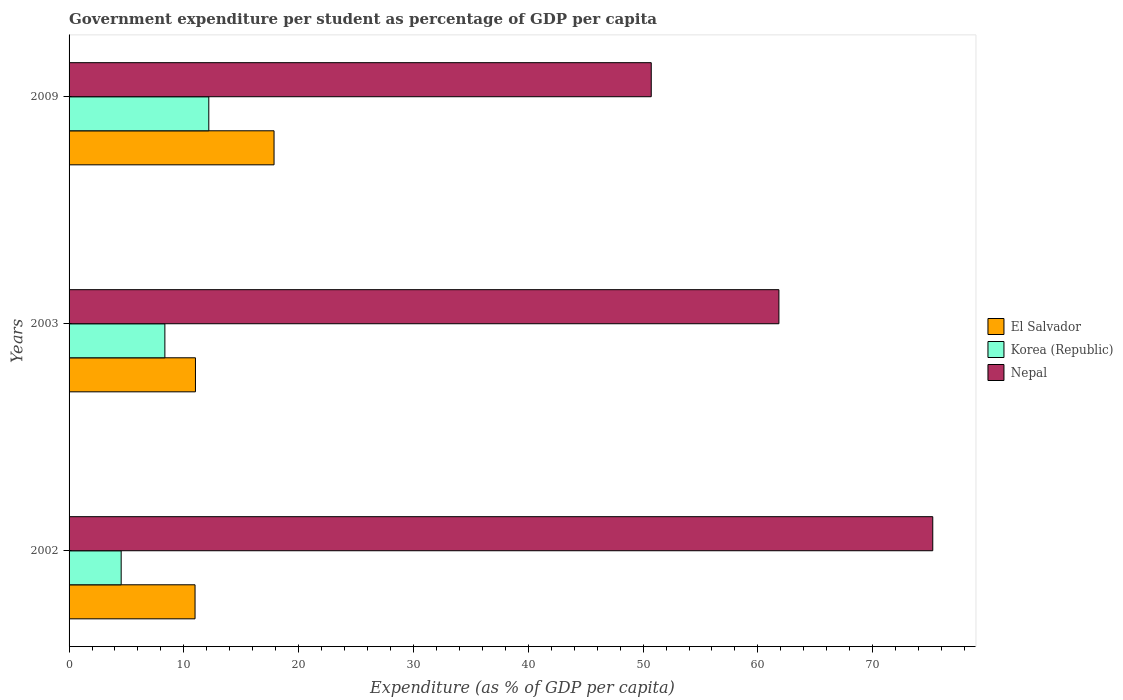Are the number of bars per tick equal to the number of legend labels?
Offer a very short reply. Yes. What is the label of the 3rd group of bars from the top?
Give a very brief answer. 2002. In how many cases, is the number of bars for a given year not equal to the number of legend labels?
Your response must be concise. 0. What is the percentage of expenditure per student in Nepal in 2009?
Offer a terse response. 50.71. Across all years, what is the maximum percentage of expenditure per student in Korea (Republic)?
Ensure brevity in your answer.  12.17. Across all years, what is the minimum percentage of expenditure per student in Korea (Republic)?
Give a very brief answer. 4.54. In which year was the percentage of expenditure per student in El Salvador maximum?
Your answer should be compact. 2009. In which year was the percentage of expenditure per student in Nepal minimum?
Keep it short and to the point. 2009. What is the total percentage of expenditure per student in Nepal in the graph?
Give a very brief answer. 187.77. What is the difference between the percentage of expenditure per student in Korea (Republic) in 2003 and that in 2009?
Your answer should be very brief. -3.83. What is the difference between the percentage of expenditure per student in Nepal in 2003 and the percentage of expenditure per student in El Salvador in 2002?
Provide a succinct answer. 50.86. What is the average percentage of expenditure per student in Nepal per year?
Keep it short and to the point. 62.59. In the year 2009, what is the difference between the percentage of expenditure per student in El Salvador and percentage of expenditure per student in Korea (Republic)?
Give a very brief answer. 5.68. What is the ratio of the percentage of expenditure per student in Korea (Republic) in 2002 to that in 2003?
Provide a succinct answer. 0.54. Is the percentage of expenditure per student in Nepal in 2002 less than that in 2003?
Ensure brevity in your answer.  No. Is the difference between the percentage of expenditure per student in El Salvador in 2002 and 2009 greater than the difference between the percentage of expenditure per student in Korea (Republic) in 2002 and 2009?
Make the answer very short. Yes. What is the difference between the highest and the second highest percentage of expenditure per student in Nepal?
Provide a succinct answer. 13.4. What is the difference between the highest and the lowest percentage of expenditure per student in Nepal?
Your response must be concise. 24.52. What does the 2nd bar from the top in 2009 represents?
Provide a short and direct response. Korea (Republic). What does the 2nd bar from the bottom in 2002 represents?
Ensure brevity in your answer.  Korea (Republic). How many bars are there?
Give a very brief answer. 9. What is the difference between two consecutive major ticks on the X-axis?
Your response must be concise. 10. Are the values on the major ticks of X-axis written in scientific E-notation?
Provide a succinct answer. No. Does the graph contain any zero values?
Offer a very short reply. No. Does the graph contain grids?
Ensure brevity in your answer.  No. How many legend labels are there?
Offer a terse response. 3. How are the legend labels stacked?
Keep it short and to the point. Vertical. What is the title of the graph?
Ensure brevity in your answer.  Government expenditure per student as percentage of GDP per capita. What is the label or title of the X-axis?
Make the answer very short. Expenditure (as % of GDP per capita). What is the label or title of the Y-axis?
Keep it short and to the point. Years. What is the Expenditure (as % of GDP per capita) of El Salvador in 2002?
Keep it short and to the point. 10.97. What is the Expenditure (as % of GDP per capita) in Korea (Republic) in 2002?
Ensure brevity in your answer.  4.54. What is the Expenditure (as % of GDP per capita) in Nepal in 2002?
Keep it short and to the point. 75.23. What is the Expenditure (as % of GDP per capita) of El Salvador in 2003?
Keep it short and to the point. 11.01. What is the Expenditure (as % of GDP per capita) of Korea (Republic) in 2003?
Provide a short and direct response. 8.34. What is the Expenditure (as % of GDP per capita) of Nepal in 2003?
Keep it short and to the point. 61.83. What is the Expenditure (as % of GDP per capita) in El Salvador in 2009?
Provide a succinct answer. 17.85. What is the Expenditure (as % of GDP per capita) in Korea (Republic) in 2009?
Your answer should be very brief. 12.17. What is the Expenditure (as % of GDP per capita) of Nepal in 2009?
Your response must be concise. 50.71. Across all years, what is the maximum Expenditure (as % of GDP per capita) of El Salvador?
Provide a succinct answer. 17.85. Across all years, what is the maximum Expenditure (as % of GDP per capita) in Korea (Republic)?
Make the answer very short. 12.17. Across all years, what is the maximum Expenditure (as % of GDP per capita) in Nepal?
Offer a very short reply. 75.23. Across all years, what is the minimum Expenditure (as % of GDP per capita) of El Salvador?
Provide a short and direct response. 10.97. Across all years, what is the minimum Expenditure (as % of GDP per capita) in Korea (Republic)?
Offer a very short reply. 4.54. Across all years, what is the minimum Expenditure (as % of GDP per capita) of Nepal?
Give a very brief answer. 50.71. What is the total Expenditure (as % of GDP per capita) in El Salvador in the graph?
Ensure brevity in your answer.  39.84. What is the total Expenditure (as % of GDP per capita) of Korea (Republic) in the graph?
Keep it short and to the point. 25.05. What is the total Expenditure (as % of GDP per capita) of Nepal in the graph?
Offer a very short reply. 187.77. What is the difference between the Expenditure (as % of GDP per capita) in El Salvador in 2002 and that in 2003?
Your answer should be very brief. -0.04. What is the difference between the Expenditure (as % of GDP per capita) in Korea (Republic) in 2002 and that in 2003?
Make the answer very short. -3.81. What is the difference between the Expenditure (as % of GDP per capita) of Nepal in 2002 and that in 2003?
Keep it short and to the point. 13.4. What is the difference between the Expenditure (as % of GDP per capita) of El Salvador in 2002 and that in 2009?
Your response must be concise. -6.88. What is the difference between the Expenditure (as % of GDP per capita) in Korea (Republic) in 2002 and that in 2009?
Make the answer very short. -7.63. What is the difference between the Expenditure (as % of GDP per capita) in Nepal in 2002 and that in 2009?
Offer a very short reply. 24.52. What is the difference between the Expenditure (as % of GDP per capita) of El Salvador in 2003 and that in 2009?
Give a very brief answer. -6.85. What is the difference between the Expenditure (as % of GDP per capita) in Korea (Republic) in 2003 and that in 2009?
Provide a succinct answer. -3.83. What is the difference between the Expenditure (as % of GDP per capita) in Nepal in 2003 and that in 2009?
Make the answer very short. 11.12. What is the difference between the Expenditure (as % of GDP per capita) of El Salvador in 2002 and the Expenditure (as % of GDP per capita) of Korea (Republic) in 2003?
Provide a succinct answer. 2.63. What is the difference between the Expenditure (as % of GDP per capita) in El Salvador in 2002 and the Expenditure (as % of GDP per capita) in Nepal in 2003?
Keep it short and to the point. -50.86. What is the difference between the Expenditure (as % of GDP per capita) of Korea (Republic) in 2002 and the Expenditure (as % of GDP per capita) of Nepal in 2003?
Provide a short and direct response. -57.29. What is the difference between the Expenditure (as % of GDP per capita) in El Salvador in 2002 and the Expenditure (as % of GDP per capita) in Korea (Republic) in 2009?
Offer a very short reply. -1.2. What is the difference between the Expenditure (as % of GDP per capita) of El Salvador in 2002 and the Expenditure (as % of GDP per capita) of Nepal in 2009?
Make the answer very short. -39.74. What is the difference between the Expenditure (as % of GDP per capita) in Korea (Republic) in 2002 and the Expenditure (as % of GDP per capita) in Nepal in 2009?
Ensure brevity in your answer.  -46.17. What is the difference between the Expenditure (as % of GDP per capita) in El Salvador in 2003 and the Expenditure (as % of GDP per capita) in Korea (Republic) in 2009?
Offer a terse response. -1.16. What is the difference between the Expenditure (as % of GDP per capita) in El Salvador in 2003 and the Expenditure (as % of GDP per capita) in Nepal in 2009?
Your answer should be compact. -39.7. What is the difference between the Expenditure (as % of GDP per capita) in Korea (Republic) in 2003 and the Expenditure (as % of GDP per capita) in Nepal in 2009?
Your answer should be compact. -42.37. What is the average Expenditure (as % of GDP per capita) of El Salvador per year?
Provide a succinct answer. 13.28. What is the average Expenditure (as % of GDP per capita) of Korea (Republic) per year?
Your answer should be very brief. 8.35. What is the average Expenditure (as % of GDP per capita) in Nepal per year?
Provide a succinct answer. 62.59. In the year 2002, what is the difference between the Expenditure (as % of GDP per capita) in El Salvador and Expenditure (as % of GDP per capita) in Korea (Republic)?
Provide a short and direct response. 6.44. In the year 2002, what is the difference between the Expenditure (as % of GDP per capita) in El Salvador and Expenditure (as % of GDP per capita) in Nepal?
Give a very brief answer. -64.26. In the year 2002, what is the difference between the Expenditure (as % of GDP per capita) in Korea (Republic) and Expenditure (as % of GDP per capita) in Nepal?
Keep it short and to the point. -70.69. In the year 2003, what is the difference between the Expenditure (as % of GDP per capita) in El Salvador and Expenditure (as % of GDP per capita) in Korea (Republic)?
Provide a succinct answer. 2.66. In the year 2003, what is the difference between the Expenditure (as % of GDP per capita) in El Salvador and Expenditure (as % of GDP per capita) in Nepal?
Provide a succinct answer. -50.82. In the year 2003, what is the difference between the Expenditure (as % of GDP per capita) in Korea (Republic) and Expenditure (as % of GDP per capita) in Nepal?
Provide a short and direct response. -53.49. In the year 2009, what is the difference between the Expenditure (as % of GDP per capita) in El Salvador and Expenditure (as % of GDP per capita) in Korea (Republic)?
Ensure brevity in your answer.  5.68. In the year 2009, what is the difference between the Expenditure (as % of GDP per capita) of El Salvador and Expenditure (as % of GDP per capita) of Nepal?
Offer a terse response. -32.86. In the year 2009, what is the difference between the Expenditure (as % of GDP per capita) of Korea (Republic) and Expenditure (as % of GDP per capita) of Nepal?
Provide a succinct answer. -38.54. What is the ratio of the Expenditure (as % of GDP per capita) of Korea (Republic) in 2002 to that in 2003?
Keep it short and to the point. 0.54. What is the ratio of the Expenditure (as % of GDP per capita) of Nepal in 2002 to that in 2003?
Make the answer very short. 1.22. What is the ratio of the Expenditure (as % of GDP per capita) in El Salvador in 2002 to that in 2009?
Give a very brief answer. 0.61. What is the ratio of the Expenditure (as % of GDP per capita) of Korea (Republic) in 2002 to that in 2009?
Give a very brief answer. 0.37. What is the ratio of the Expenditure (as % of GDP per capita) of Nepal in 2002 to that in 2009?
Give a very brief answer. 1.48. What is the ratio of the Expenditure (as % of GDP per capita) in El Salvador in 2003 to that in 2009?
Ensure brevity in your answer.  0.62. What is the ratio of the Expenditure (as % of GDP per capita) of Korea (Republic) in 2003 to that in 2009?
Your answer should be very brief. 0.69. What is the ratio of the Expenditure (as % of GDP per capita) in Nepal in 2003 to that in 2009?
Offer a terse response. 1.22. What is the difference between the highest and the second highest Expenditure (as % of GDP per capita) of El Salvador?
Make the answer very short. 6.85. What is the difference between the highest and the second highest Expenditure (as % of GDP per capita) of Korea (Republic)?
Provide a short and direct response. 3.83. What is the difference between the highest and the second highest Expenditure (as % of GDP per capita) in Nepal?
Offer a very short reply. 13.4. What is the difference between the highest and the lowest Expenditure (as % of GDP per capita) in El Salvador?
Your answer should be compact. 6.88. What is the difference between the highest and the lowest Expenditure (as % of GDP per capita) of Korea (Republic)?
Keep it short and to the point. 7.63. What is the difference between the highest and the lowest Expenditure (as % of GDP per capita) in Nepal?
Provide a short and direct response. 24.52. 